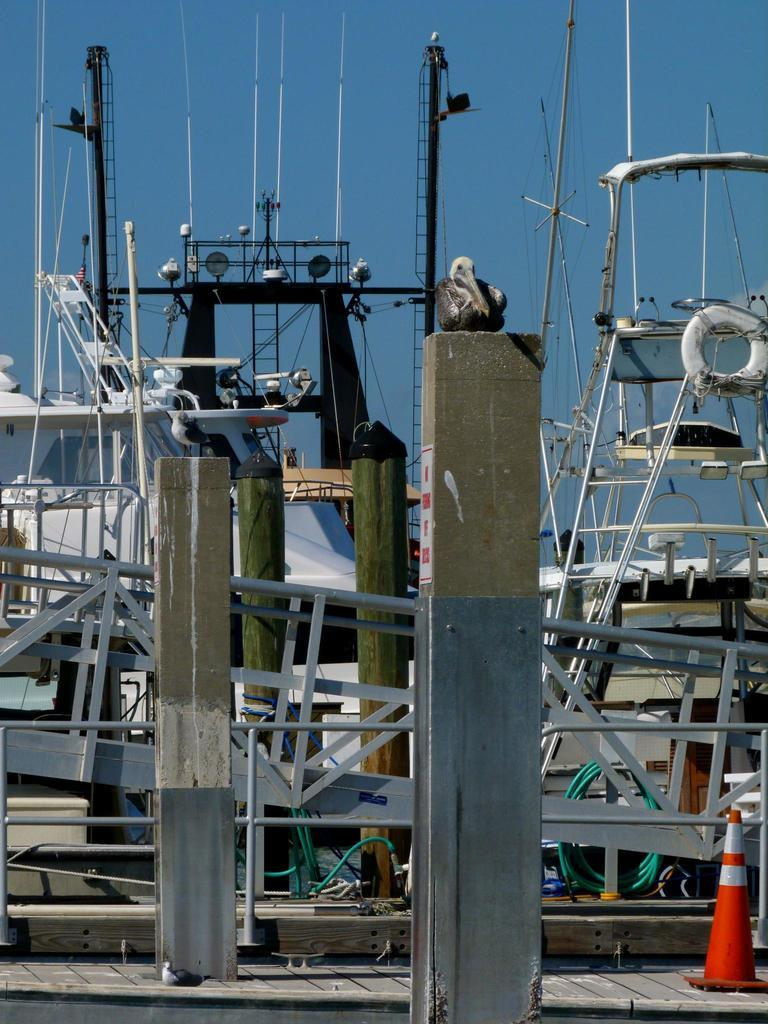What type of infrastructure can be seen in the image? Power line cables, poles, rods, and pipes are visible in the image. What is the purpose of the poles in the image? The poles are likely used to support the power line cables and other infrastructure elements. What is the divider block used for in the image? The divider block is likely used to separate or organize the various infrastructure elements. What is visible at the top of the image? The sky is visible at the top of the image. What type of cast can be seen on the person's arm in the image? There is no person or cast present in the image; it features infrastructure elements such as power line cables, poles, rods, and pipes. What type of spoon is used to exchange information between the pipes in the image? There is no spoon or exchange of information between pipes present in the image; it only shows various infrastructure elements. 